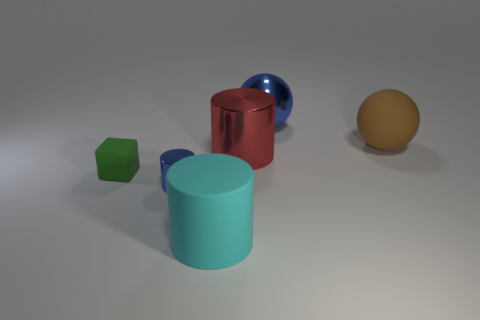Add 2 tiny cyan matte balls. How many objects exist? 8 Subtract all blocks. How many objects are left? 5 Subtract all large rubber things. Subtract all tiny matte cylinders. How many objects are left? 4 Add 6 big red shiny cylinders. How many big red shiny cylinders are left? 7 Add 5 big metal objects. How many big metal objects exist? 7 Subtract 0 green cylinders. How many objects are left? 6 